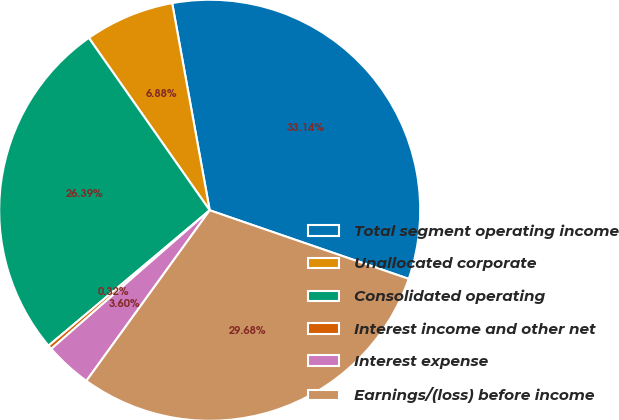<chart> <loc_0><loc_0><loc_500><loc_500><pie_chart><fcel>Total segment operating income<fcel>Unallocated corporate<fcel>Consolidated operating<fcel>Interest income and other net<fcel>Interest expense<fcel>Earnings/(loss) before income<nl><fcel>33.14%<fcel>6.88%<fcel>26.39%<fcel>0.32%<fcel>3.6%<fcel>29.68%<nl></chart> 